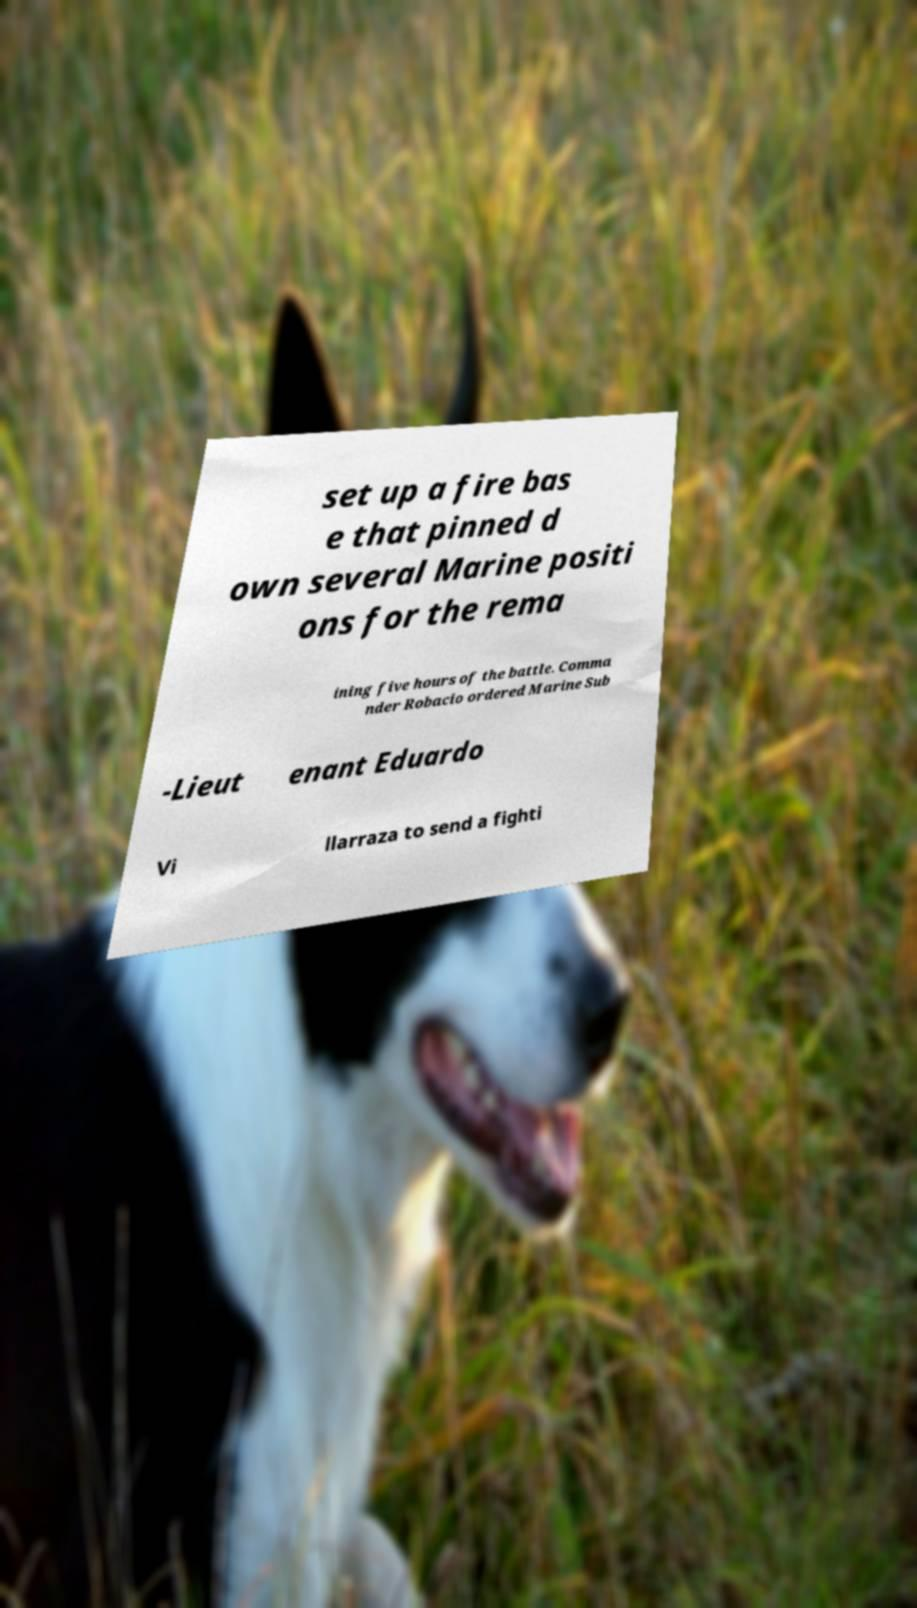Could you extract and type out the text from this image? set up a fire bas e that pinned d own several Marine positi ons for the rema ining five hours of the battle. Comma nder Robacio ordered Marine Sub -Lieut enant Eduardo Vi llarraza to send a fighti 